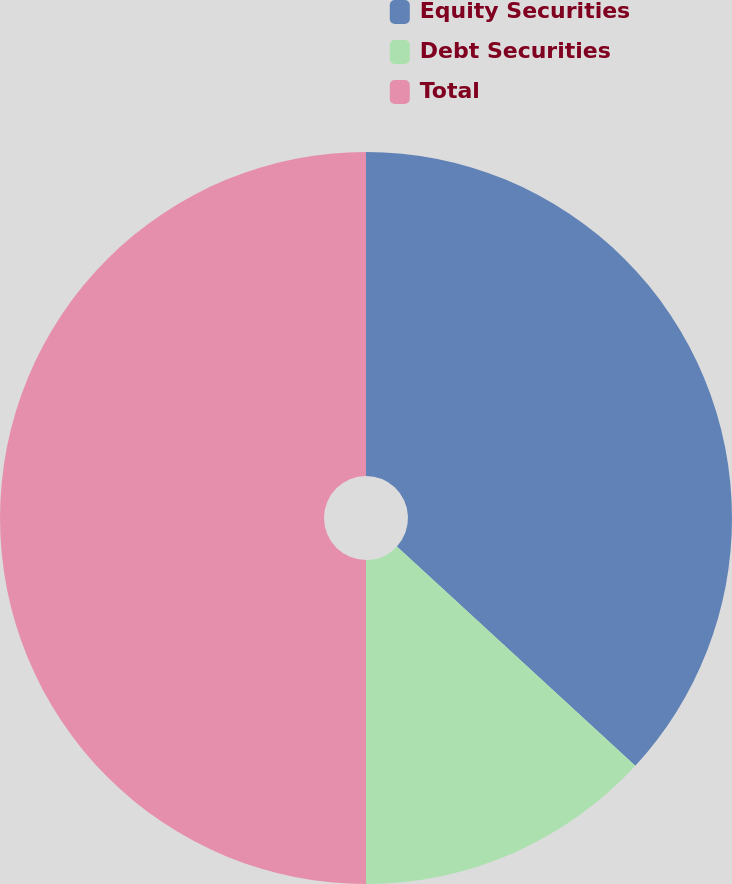<chart> <loc_0><loc_0><loc_500><loc_500><pie_chart><fcel>Equity Securities<fcel>Debt Securities<fcel>Total<nl><fcel>36.84%<fcel>13.16%<fcel>50.0%<nl></chart> 